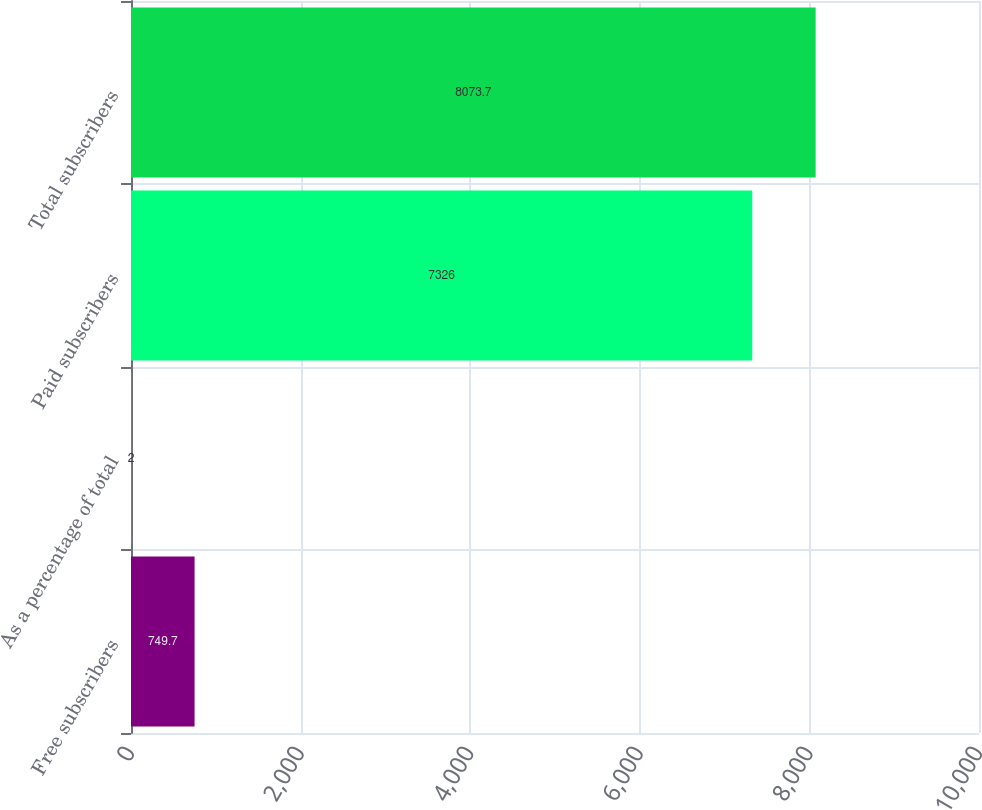Convert chart to OTSL. <chart><loc_0><loc_0><loc_500><loc_500><bar_chart><fcel>Free subscribers<fcel>As a percentage of total<fcel>Paid subscribers<fcel>Total subscribers<nl><fcel>749.7<fcel>2<fcel>7326<fcel>8073.7<nl></chart> 